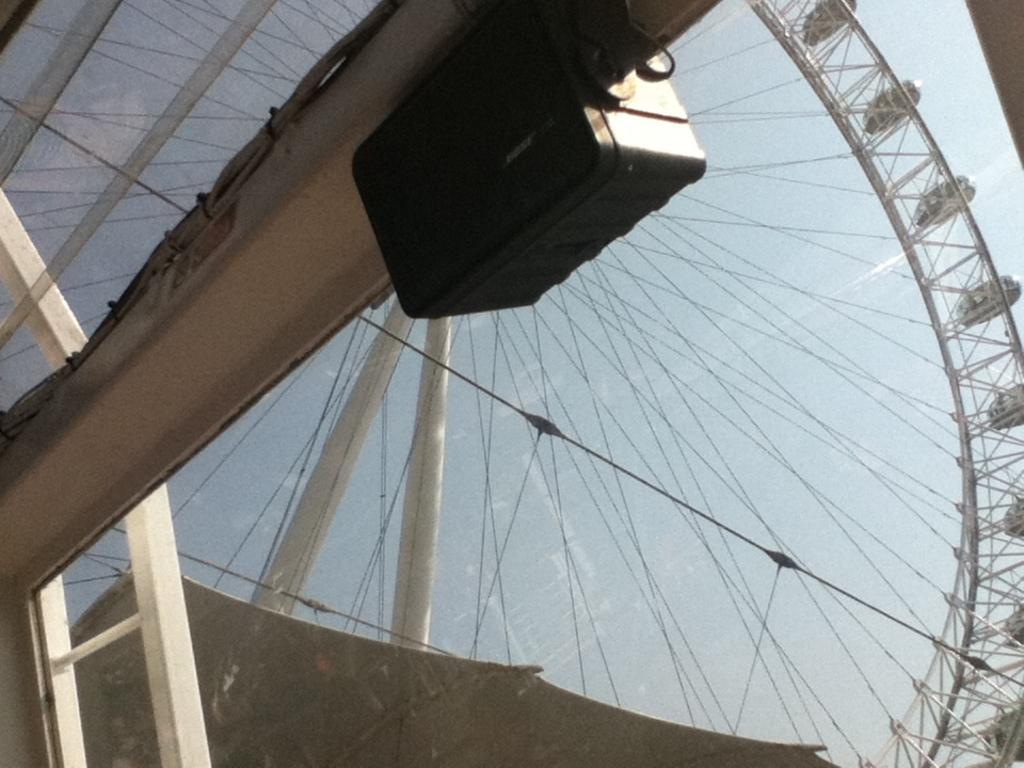Describe this image in one or two sentences. In this image I can see a metal rod which is white in color to there is a black colored object attached. In the background I can see a giant wheel which is white in color, few wires, a tent and the sky. 